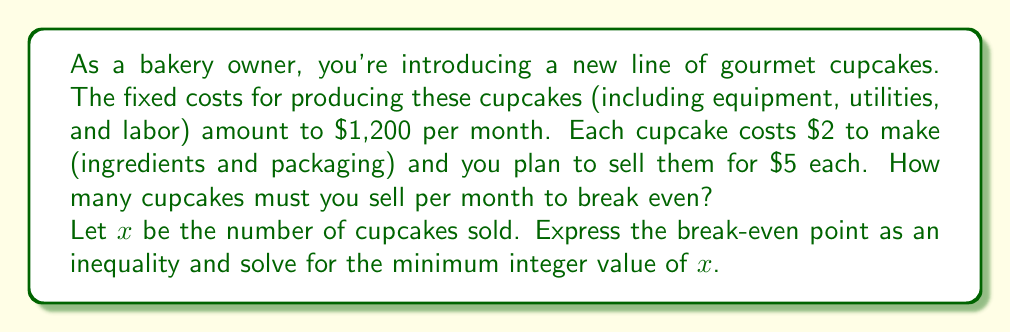Provide a solution to this math problem. To solve this problem, we'll follow these steps:

1) First, let's define our variables:
   $x$ = number of cupcakes sold
   Fixed costs = $1,200
   Variable cost per cupcake = $2
   Selling price per cupcake = $5

2) The break-even point occurs when total revenue equals total costs:
   Total Revenue = Total Costs
   
3) We can express this as an equation:
   $5x = 1200 + 2x$

4) This can be rewritten as an inequality to find the point where profit begins:
   $5x > 1200 + 2x$

5) Solve the inequality:
   $5x - 2x > 1200$
   $3x > 1200$
   $x > 400$

6) Since we can't sell a fractional cupcake, we need to round up to the next whole number.

Therefore, the bakery needs to sell at least 401 cupcakes to break even.

To verify:
Revenue from 401 cupcakes: $401 * $5 = $2,005
Costs for 401 cupcakes: $1,200 + ($2 * 401) = $2,002

$2,005 > $2,002, confirming that 401 cupcakes result in a small profit.
Answer: The bakery must sell a minimum of 401 cupcakes per month to break even. 